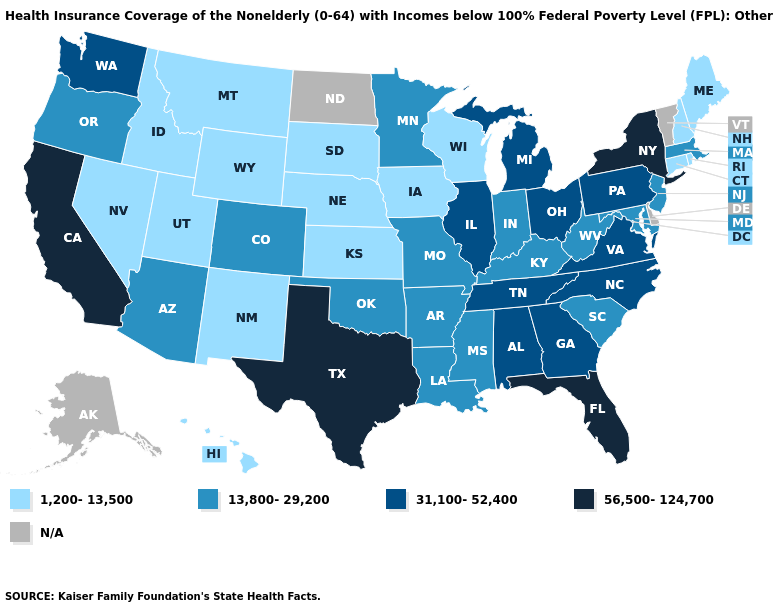Among the states that border Oregon , does Washington have the lowest value?
Give a very brief answer. No. What is the lowest value in the USA?
Write a very short answer. 1,200-13,500. Does the map have missing data?
Write a very short answer. Yes. Does the first symbol in the legend represent the smallest category?
Be succinct. Yes. Name the states that have a value in the range 13,800-29,200?
Write a very short answer. Arizona, Arkansas, Colorado, Indiana, Kentucky, Louisiana, Maryland, Massachusetts, Minnesota, Mississippi, Missouri, New Jersey, Oklahoma, Oregon, South Carolina, West Virginia. What is the highest value in states that border Vermont?
Quick response, please. 56,500-124,700. What is the value of Missouri?
Short answer required. 13,800-29,200. What is the value of Missouri?
Concise answer only. 13,800-29,200. Name the states that have a value in the range 56,500-124,700?
Quick response, please. California, Florida, New York, Texas. Which states have the lowest value in the West?
Be succinct. Hawaii, Idaho, Montana, Nevada, New Mexico, Utah, Wyoming. Does the map have missing data?
Answer briefly. Yes. Among the states that border California , does Oregon have the highest value?
Give a very brief answer. Yes. Among the states that border New Hampshire , which have the highest value?
Short answer required. Massachusetts. What is the value of Missouri?
Write a very short answer. 13,800-29,200. 